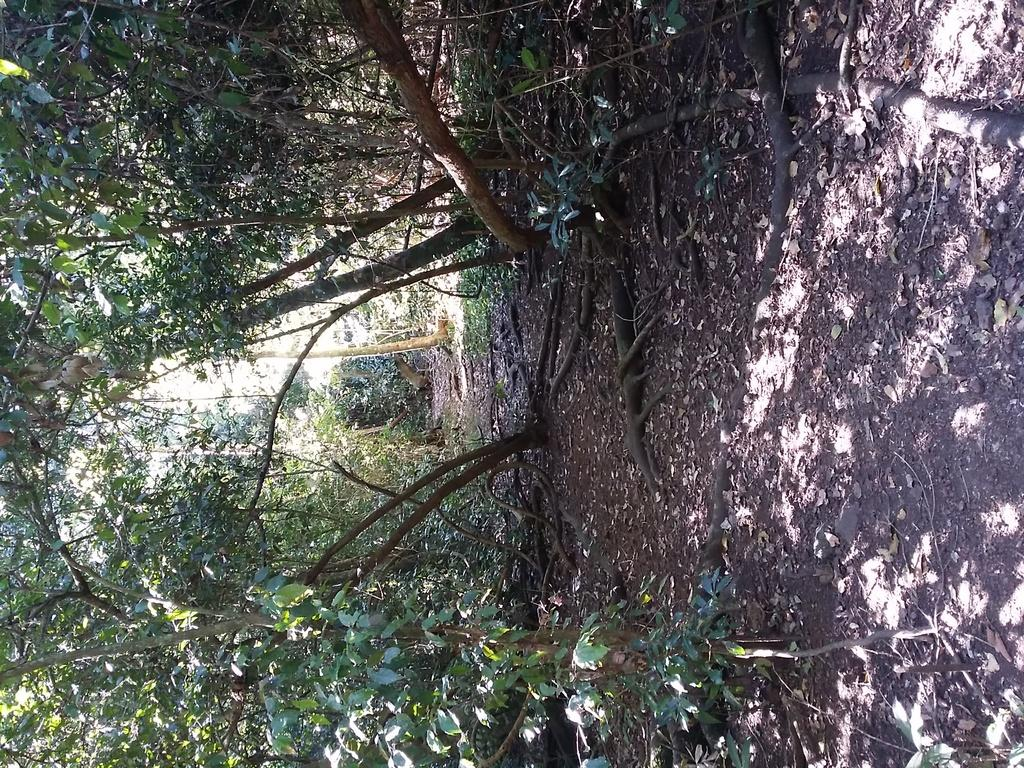What type of vegetation is present in the image? There are trees in the image. Can you describe any specific features of the trees? The bark of a tree is visible in the image. What type of ground cover can be seen in the image? There is land with dried leaves in the image. How many rabbits can be seen playing with a jewel in the image? There are no rabbits or jewels present in the image; it features trees and land with dried leaves. 